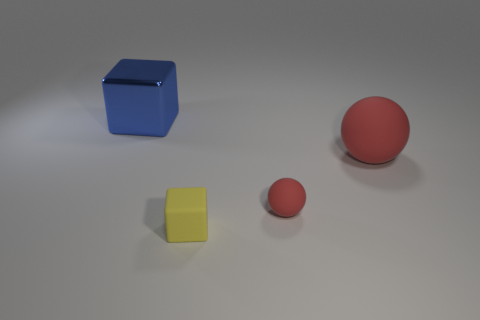Are there any red objects that have the same material as the tiny yellow object?
Keep it short and to the point. Yes. There is a thing that is the same color as the big matte ball; what size is it?
Give a very brief answer. Small. How many things are both on the left side of the large red matte object and to the right of the large blue block?
Provide a short and direct response. 2. What material is the red ball right of the tiny red sphere?
Ensure brevity in your answer.  Rubber. What number of big matte things are the same color as the tiny ball?
Offer a very short reply. 1. What is the size of the red object that is the same material as the small red ball?
Make the answer very short. Large. How many objects are either large green shiny cylinders or red matte spheres?
Keep it short and to the point. 2. The matte thing in front of the small matte ball is what color?
Offer a very short reply. Yellow. What size is the other object that is the same shape as the yellow matte thing?
Ensure brevity in your answer.  Large. How many objects are either spheres in front of the large red rubber ball or red spheres left of the large sphere?
Ensure brevity in your answer.  1. 